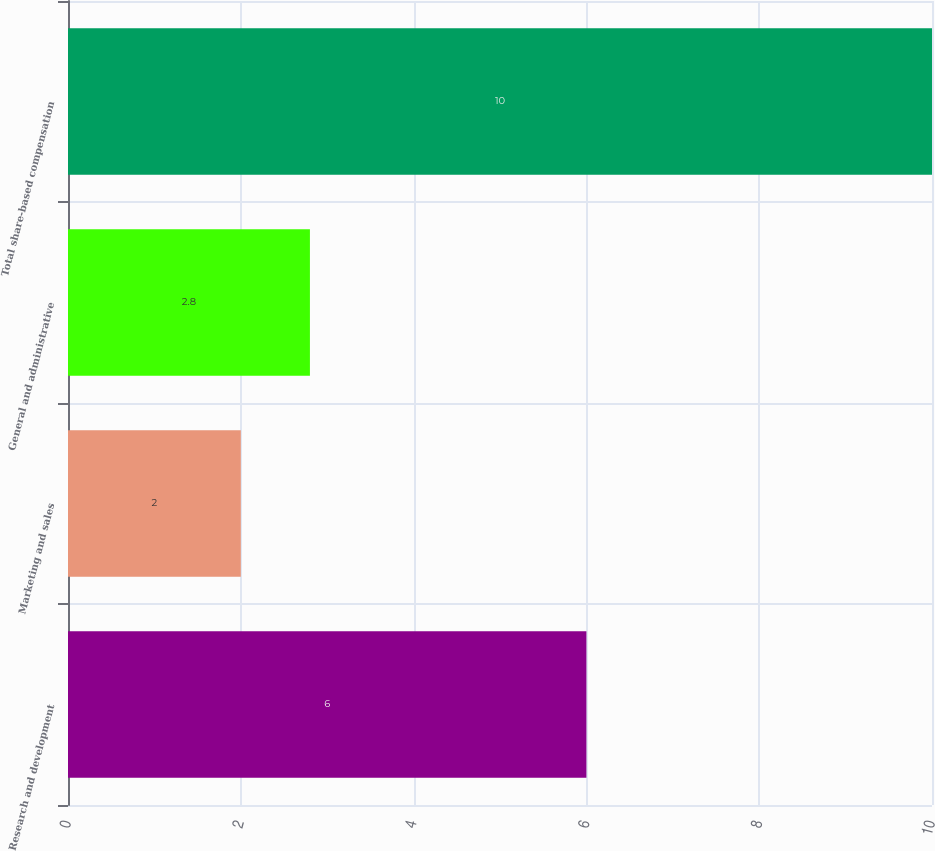Convert chart to OTSL. <chart><loc_0><loc_0><loc_500><loc_500><bar_chart><fcel>Research and development<fcel>Marketing and sales<fcel>General and administrative<fcel>Total share-based compensation<nl><fcel>6<fcel>2<fcel>2.8<fcel>10<nl></chart> 